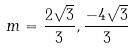<formula> <loc_0><loc_0><loc_500><loc_500>m = \frac { 2 \sqrt { 3 } } { 3 } , \frac { - 4 \sqrt { 3 } } { 3 }</formula> 